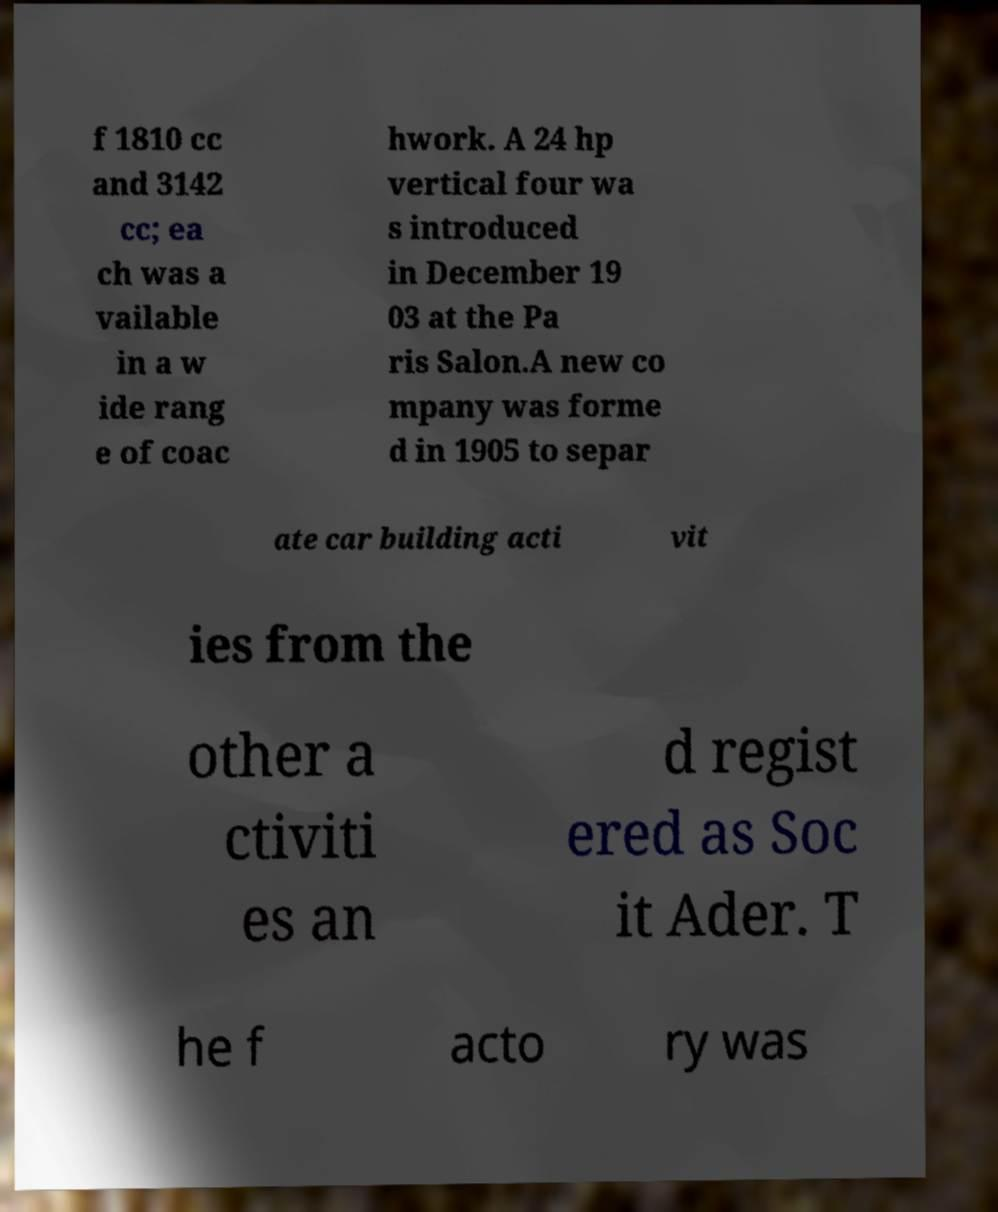What messages or text are displayed in this image? I need them in a readable, typed format. f 1810 cc and 3142 cc; ea ch was a vailable in a w ide rang e of coac hwork. A 24 hp vertical four wa s introduced in December 19 03 at the Pa ris Salon.A new co mpany was forme d in 1905 to separ ate car building acti vit ies from the other a ctiviti es an d regist ered as Soc it Ader. T he f acto ry was 